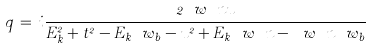<formula> <loc_0><loc_0><loc_500><loc_500>q \, = \, i \frac { 2 \ w _ { \ } n u } { E _ { k } ^ { 2 } + t ^ { 2 } - E _ { k } \ w _ { b } - u ^ { 2 } + E _ { k } \ w _ { \ } n - \ w _ { \ } n \ w _ { b } }</formula> 